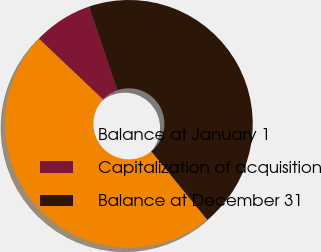Convert chart to OTSL. <chart><loc_0><loc_0><loc_500><loc_500><pie_chart><fcel>Balance at January 1<fcel>Capitalization of acquisition<fcel>Balance at December 31<nl><fcel>47.98%<fcel>7.7%<fcel>44.32%<nl></chart> 